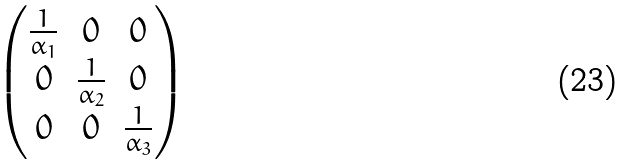Convert formula to latex. <formula><loc_0><loc_0><loc_500><loc_500>\begin{pmatrix} \frac { 1 } { \alpha _ { 1 } } & 0 & 0 \\ 0 & \frac { 1 } { \alpha _ { 2 } } & 0 \\ 0 & 0 & \frac { 1 } { \alpha _ { 3 } } \end{pmatrix}</formula> 